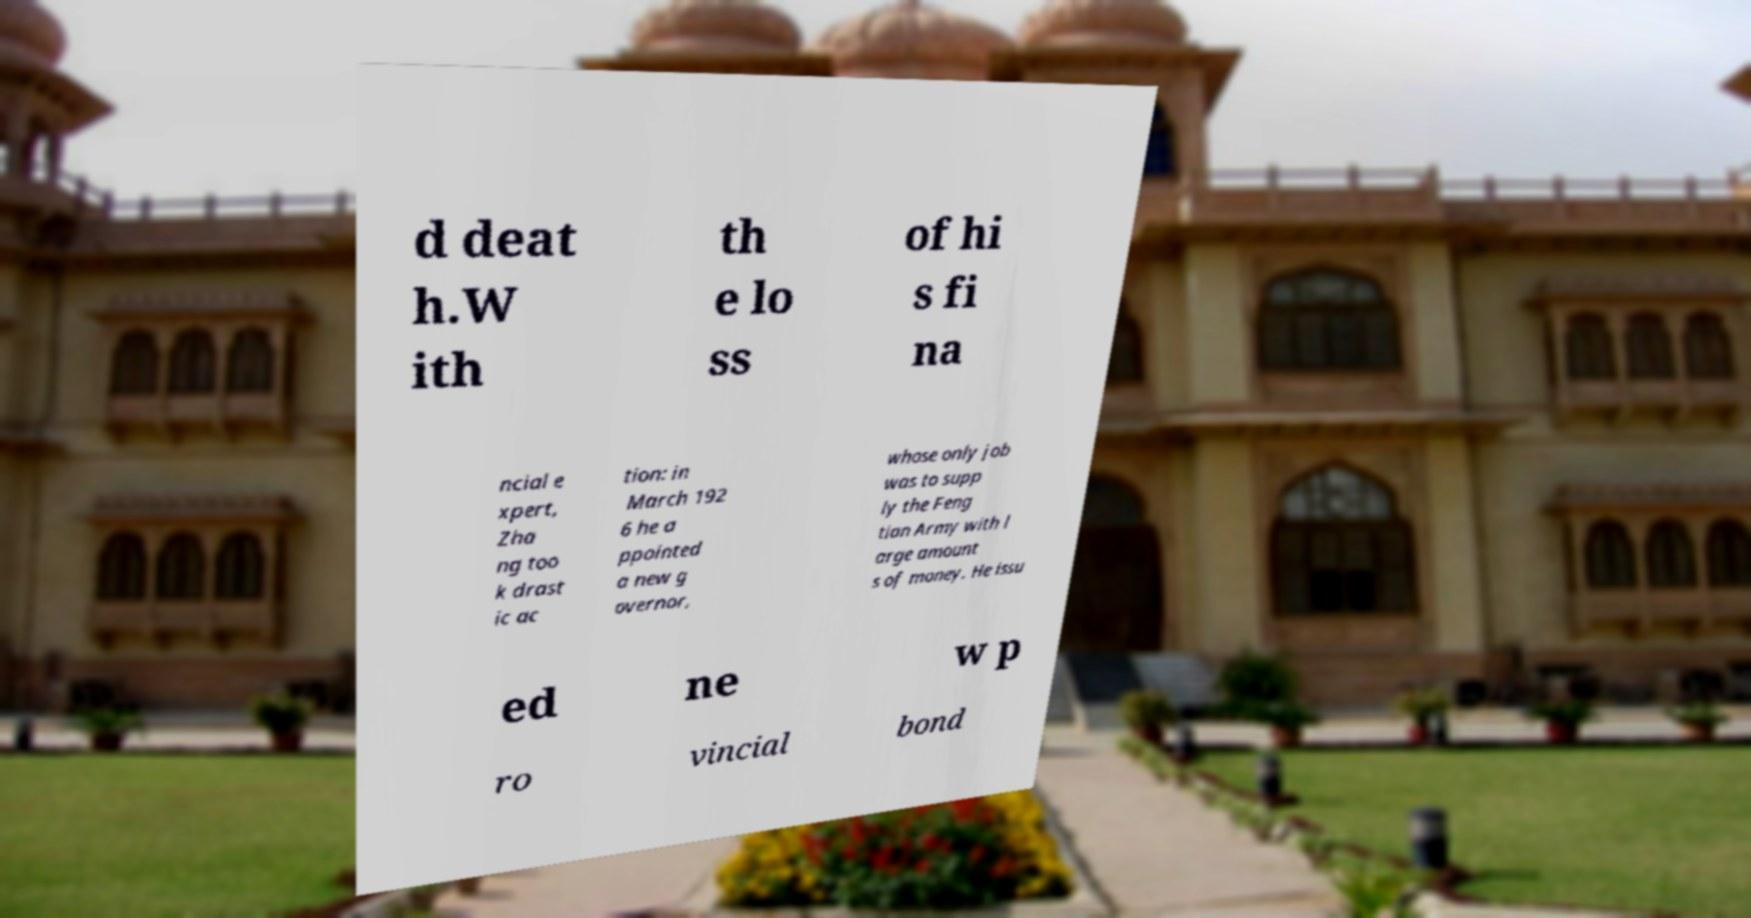Can you accurately transcribe the text from the provided image for me? d deat h.W ith th e lo ss of hi s fi na ncial e xpert, Zha ng too k drast ic ac tion: in March 192 6 he a ppointed a new g overnor, whose only job was to supp ly the Feng tian Army with l arge amount s of money. He issu ed ne w p ro vincial bond 